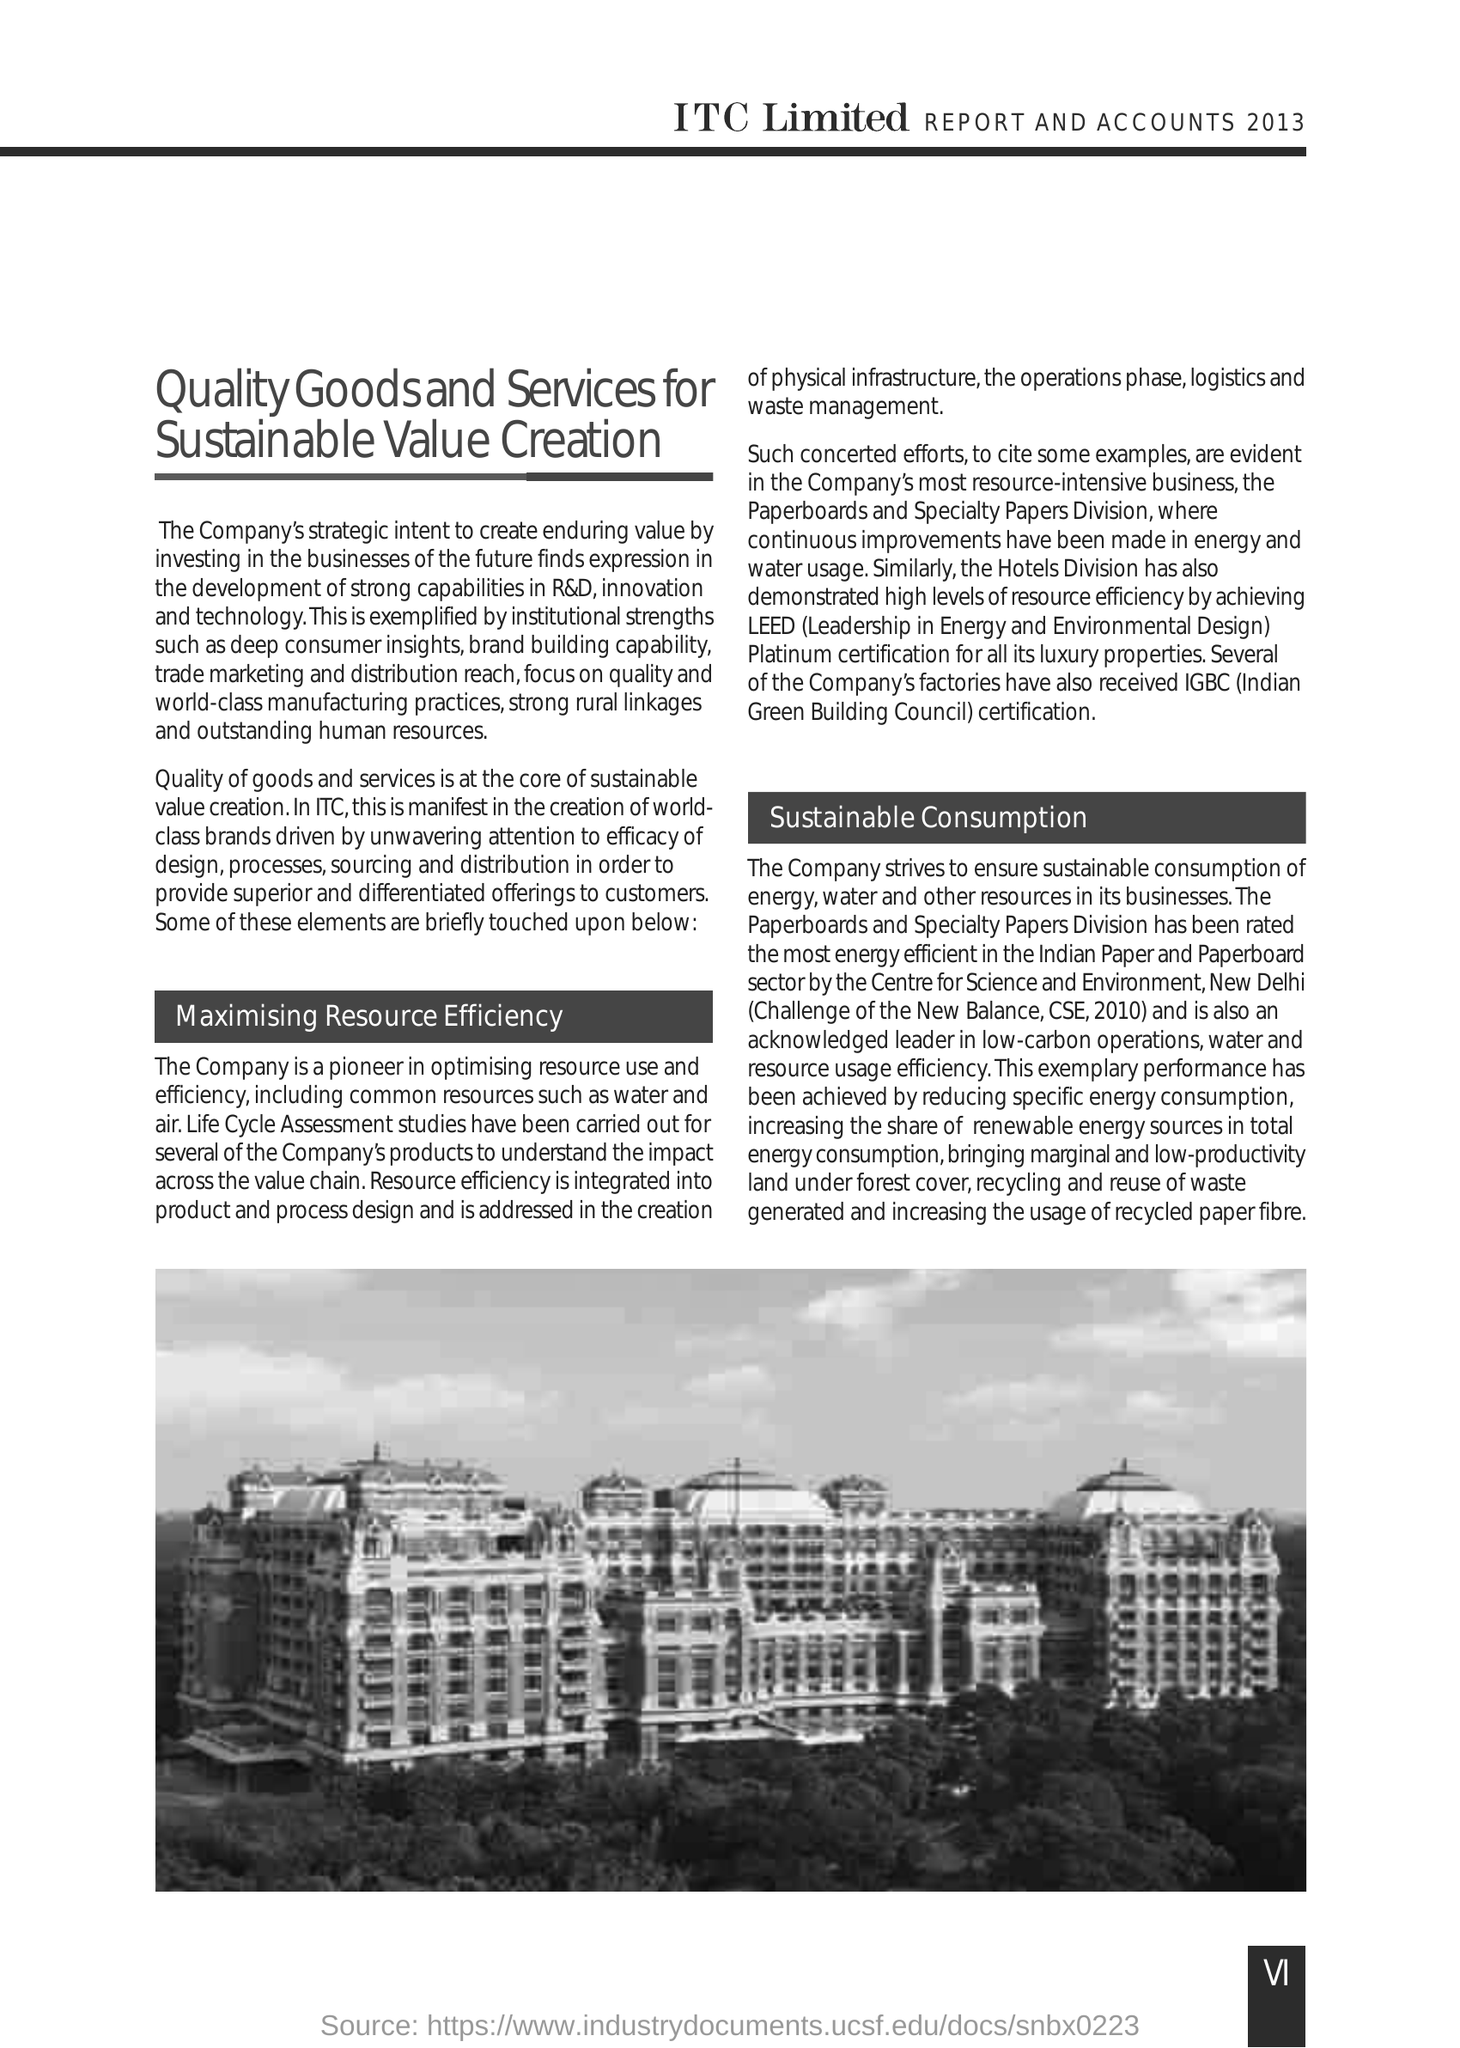What is the Fullform of CSE ?
Offer a terse response. Centre for  Science and Environment. What is the Fullform of IGBC ?
Ensure brevity in your answer.  Indian Green Building Council. 